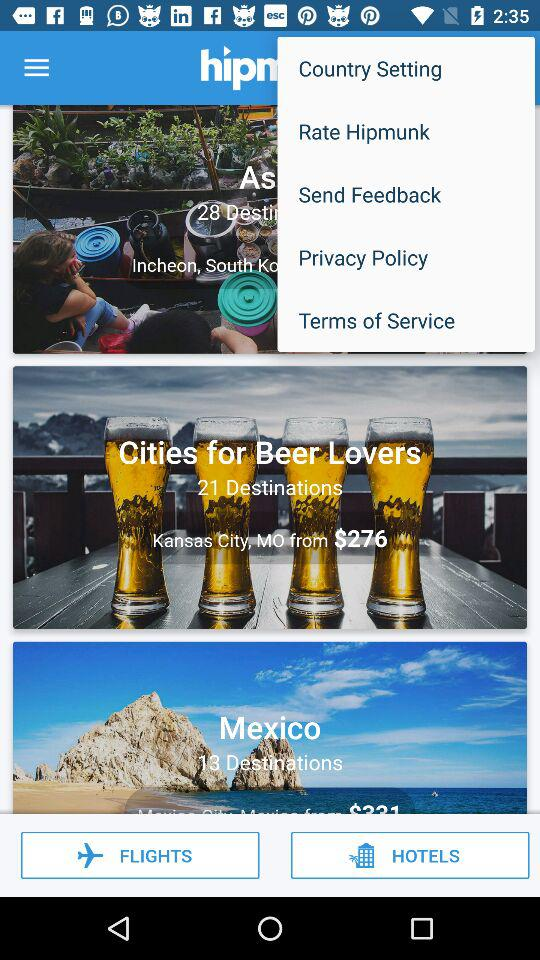Which city has 13 destinations? The city with 13 destinations is Mexico. 